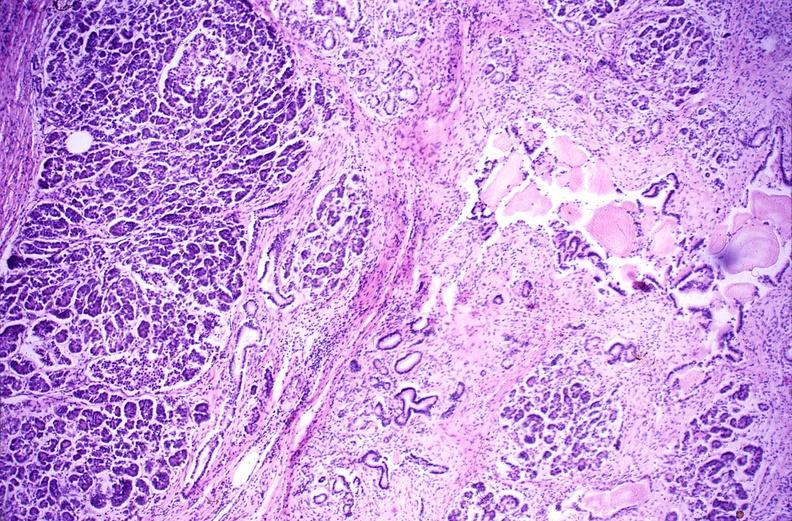where is this?
Answer the question using a single word or phrase. Pancreas 